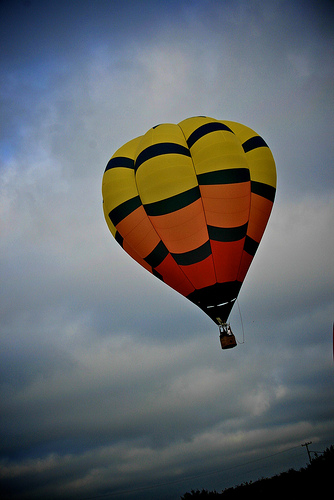<image>
Can you confirm if the balloon is in the sky? Yes. The balloon is contained within or inside the sky, showing a containment relationship. 